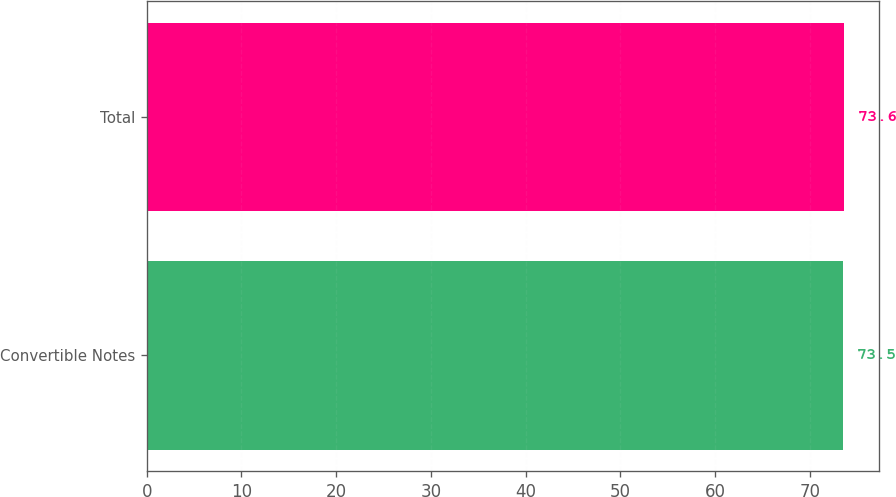Convert chart to OTSL. <chart><loc_0><loc_0><loc_500><loc_500><bar_chart><fcel>Convertible Notes<fcel>Total<nl><fcel>73.5<fcel>73.6<nl></chart> 